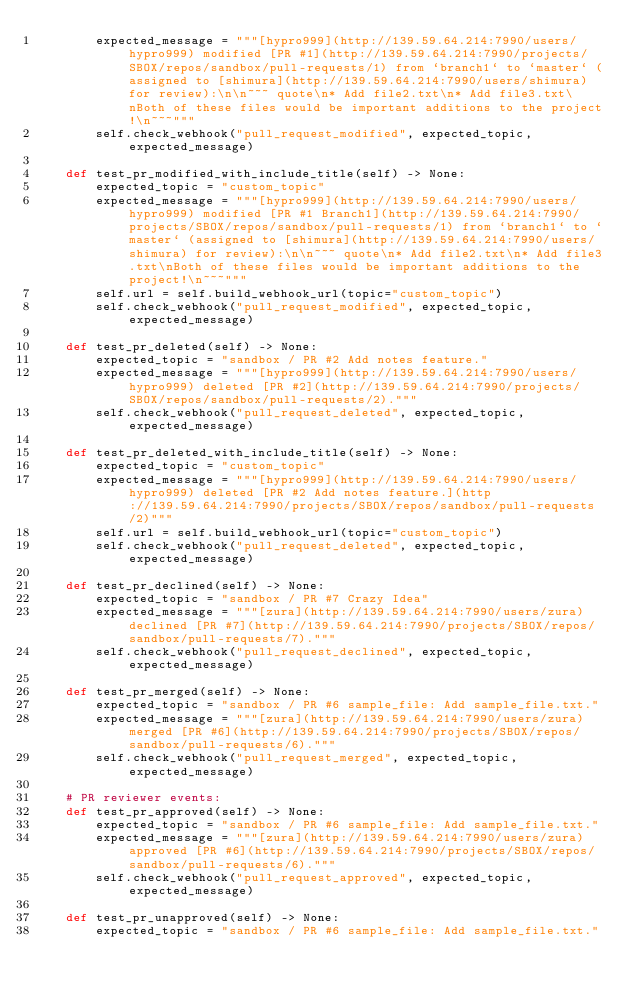<code> <loc_0><loc_0><loc_500><loc_500><_Python_>        expected_message = """[hypro999](http://139.59.64.214:7990/users/hypro999) modified [PR #1](http://139.59.64.214:7990/projects/SBOX/repos/sandbox/pull-requests/1) from `branch1` to `master` (assigned to [shimura](http://139.59.64.214:7990/users/shimura) for review):\n\n~~~ quote\n* Add file2.txt\n* Add file3.txt\nBoth of these files would be important additions to the project!\n~~~"""
        self.check_webhook("pull_request_modified", expected_topic, expected_message)

    def test_pr_modified_with_include_title(self) -> None:
        expected_topic = "custom_topic"
        expected_message = """[hypro999](http://139.59.64.214:7990/users/hypro999) modified [PR #1 Branch1](http://139.59.64.214:7990/projects/SBOX/repos/sandbox/pull-requests/1) from `branch1` to `master` (assigned to [shimura](http://139.59.64.214:7990/users/shimura) for review):\n\n~~~ quote\n* Add file2.txt\n* Add file3.txt\nBoth of these files would be important additions to the project!\n~~~"""
        self.url = self.build_webhook_url(topic="custom_topic")
        self.check_webhook("pull_request_modified", expected_topic, expected_message)

    def test_pr_deleted(self) -> None:
        expected_topic = "sandbox / PR #2 Add notes feature."
        expected_message = """[hypro999](http://139.59.64.214:7990/users/hypro999) deleted [PR #2](http://139.59.64.214:7990/projects/SBOX/repos/sandbox/pull-requests/2)."""
        self.check_webhook("pull_request_deleted", expected_topic, expected_message)

    def test_pr_deleted_with_include_title(self) -> None:
        expected_topic = "custom_topic"
        expected_message = """[hypro999](http://139.59.64.214:7990/users/hypro999) deleted [PR #2 Add notes feature.](http://139.59.64.214:7990/projects/SBOX/repos/sandbox/pull-requests/2)"""
        self.url = self.build_webhook_url(topic="custom_topic")
        self.check_webhook("pull_request_deleted", expected_topic, expected_message)

    def test_pr_declined(self) -> None:
        expected_topic = "sandbox / PR #7 Crazy Idea"
        expected_message = """[zura](http://139.59.64.214:7990/users/zura) declined [PR #7](http://139.59.64.214:7990/projects/SBOX/repos/sandbox/pull-requests/7)."""
        self.check_webhook("pull_request_declined", expected_topic, expected_message)

    def test_pr_merged(self) -> None:
        expected_topic = "sandbox / PR #6 sample_file: Add sample_file.txt."
        expected_message = """[zura](http://139.59.64.214:7990/users/zura) merged [PR #6](http://139.59.64.214:7990/projects/SBOX/repos/sandbox/pull-requests/6)."""
        self.check_webhook("pull_request_merged", expected_topic, expected_message)

    # PR reviewer events:
    def test_pr_approved(self) -> None:
        expected_topic = "sandbox / PR #6 sample_file: Add sample_file.txt."
        expected_message = """[zura](http://139.59.64.214:7990/users/zura) approved [PR #6](http://139.59.64.214:7990/projects/SBOX/repos/sandbox/pull-requests/6)."""
        self.check_webhook("pull_request_approved", expected_topic, expected_message)

    def test_pr_unapproved(self) -> None:
        expected_topic = "sandbox / PR #6 sample_file: Add sample_file.txt."</code> 